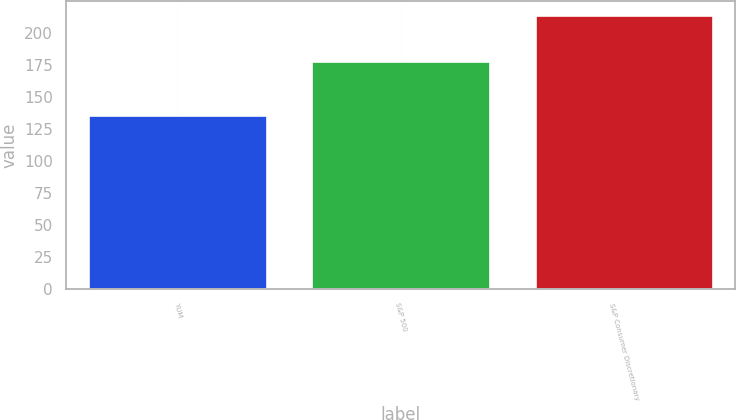Convert chart. <chart><loc_0><loc_0><loc_500><loc_500><bar_chart><fcel>YUM<fcel>S&P 500<fcel>S&P Consumer Discretionary<nl><fcel>136<fcel>178<fcel>214<nl></chart> 